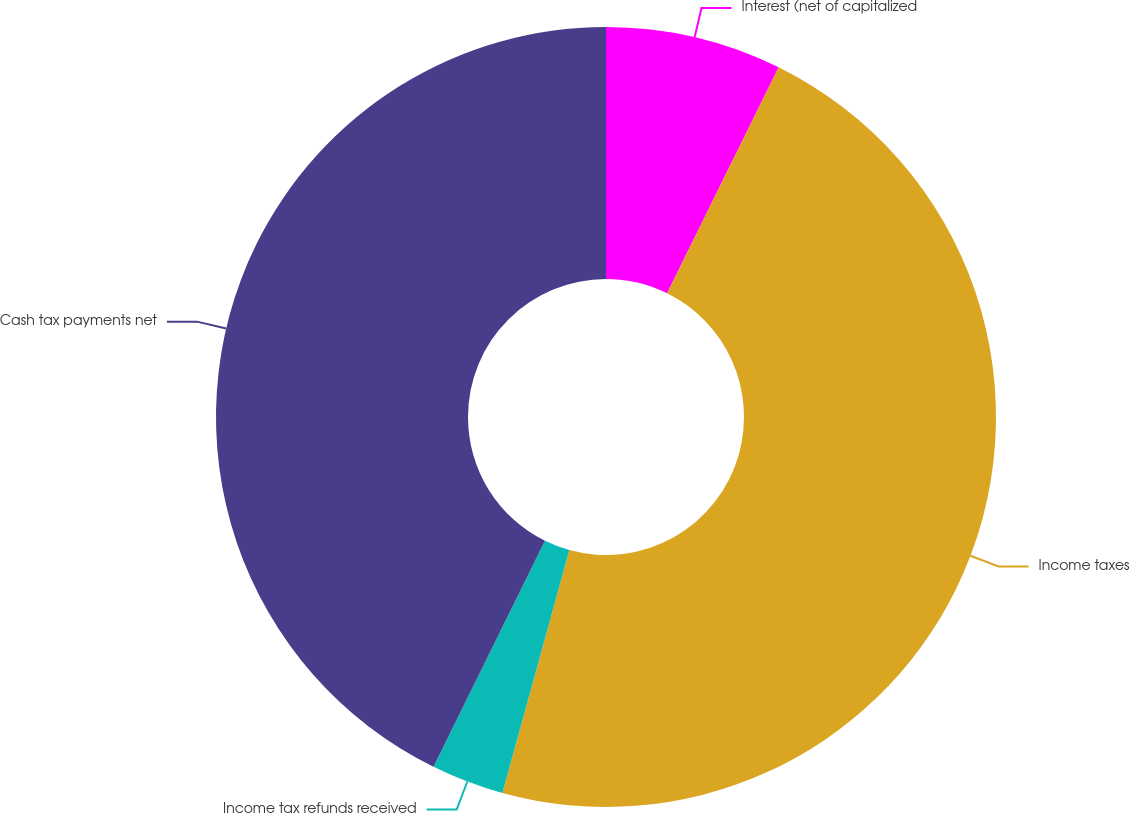Convert chart. <chart><loc_0><loc_0><loc_500><loc_500><pie_chart><fcel>Interest (net of capitalized<fcel>Income taxes<fcel>Income tax refunds received<fcel>Cash tax payments net<nl><fcel>7.3%<fcel>46.98%<fcel>3.01%<fcel>42.71%<nl></chart> 